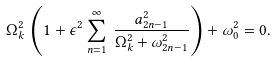Convert formula to latex. <formula><loc_0><loc_0><loc_500><loc_500>\Omega _ { k } ^ { 2 } \, \left ( 1 + \epsilon ^ { 2 } \sum _ { n = 1 } ^ { \infty } \, \frac { a _ { 2 n - 1 } ^ { 2 } } { \Omega _ { k } ^ { 2 } + \omega _ { 2 n - 1 } ^ { 2 } } \right ) + \omega _ { 0 } ^ { 2 } = 0 .</formula> 